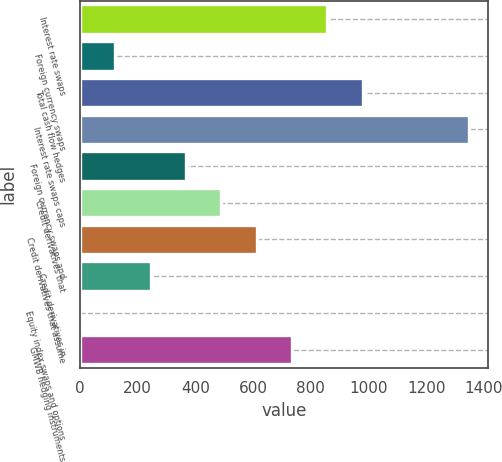Convert chart to OTSL. <chart><loc_0><loc_0><loc_500><loc_500><bar_chart><fcel>Interest rate swaps<fcel>Foreign currency swaps<fcel>Total cash flow hedges<fcel>Interest rate swaps caps<fcel>Foreign currency swaps and<fcel>Credit derivatives that<fcel>Credit derivatives that assume<fcel>Credit derivatives in<fcel>Equity index swaps and options<fcel>GMWB hedging instruments<nl><fcel>857.8<fcel>123.4<fcel>980.2<fcel>1347.4<fcel>368.2<fcel>490.6<fcel>613<fcel>245.8<fcel>1<fcel>735.4<nl></chart> 